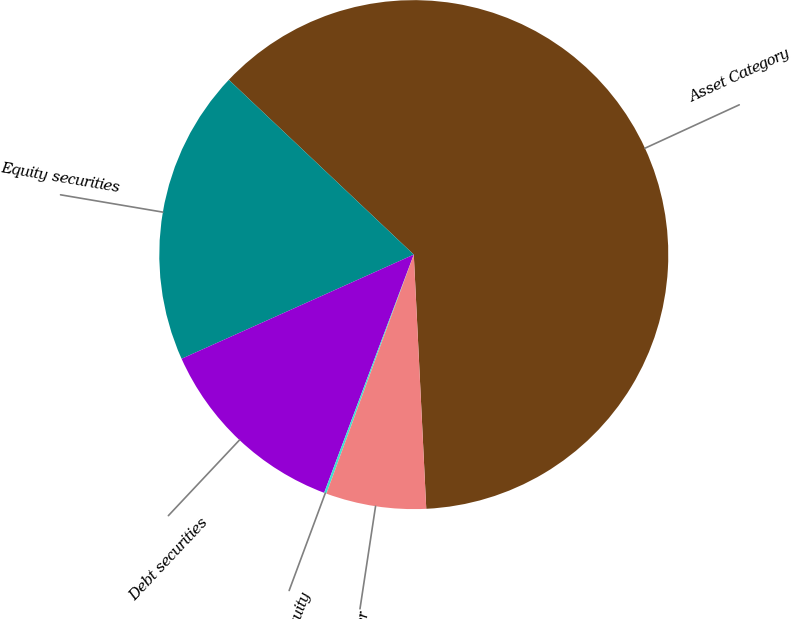Convert chart to OTSL. <chart><loc_0><loc_0><loc_500><loc_500><pie_chart><fcel>Asset Category<fcel>Equity securities<fcel>Debt securities<fcel>Private equity<fcel>Other<nl><fcel>62.17%<fcel>18.76%<fcel>12.56%<fcel>0.15%<fcel>6.36%<nl></chart> 